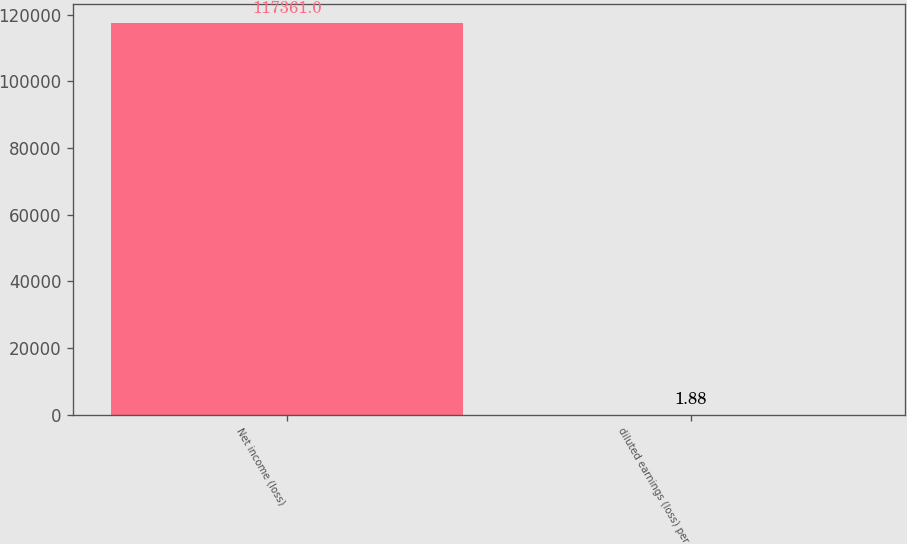<chart> <loc_0><loc_0><loc_500><loc_500><bar_chart><fcel>Net income (loss)<fcel>diluted earnings (loss) per<nl><fcel>117361<fcel>1.88<nl></chart> 